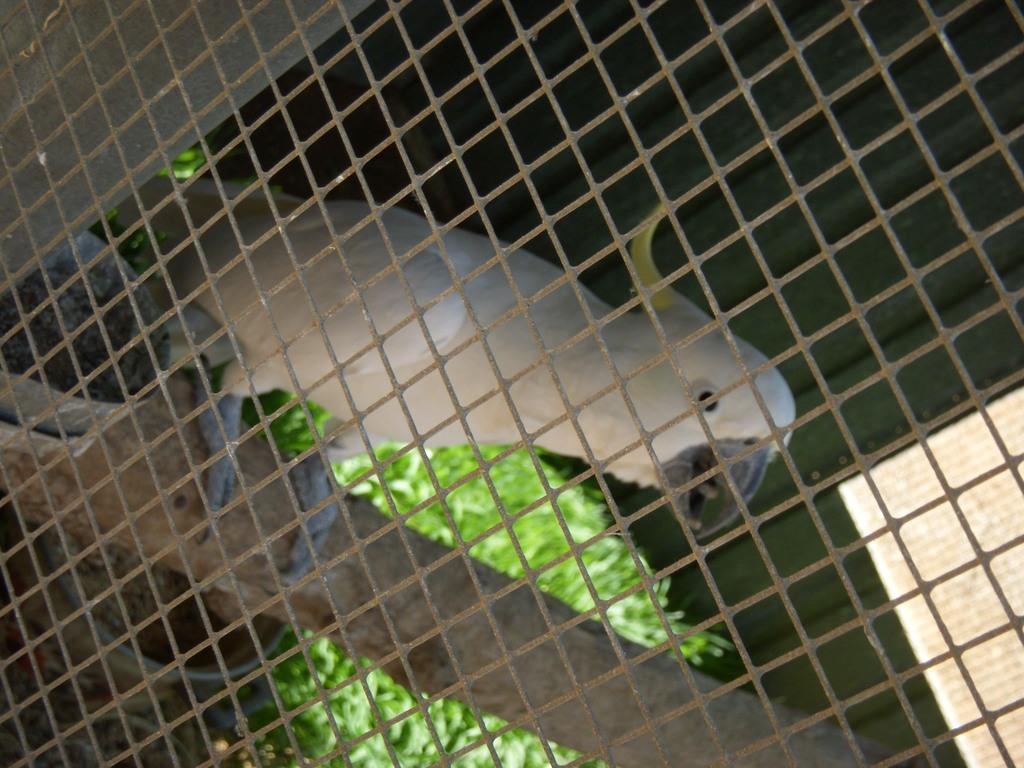What type of structure is present in the image? There is a metal cage in the image. What is inside the metal cage? There is a bird in the cage. Can you describe the bird's appearance? The bird has white, yellow, and black colors. What can be seen in the background of the image? There are trees in the background of the image. What is the color of the trees? The trees are green in color. What hobbies does the bird engage in while inside the cage? The image does not provide information about the bird's hobbies, as it only shows the bird inside the cage. How does the bird's behavior change when an apple is introduced into the cage? There is no apple present in the image, so it is impossible to determine how the bird's behavior would change in such a scenario. 